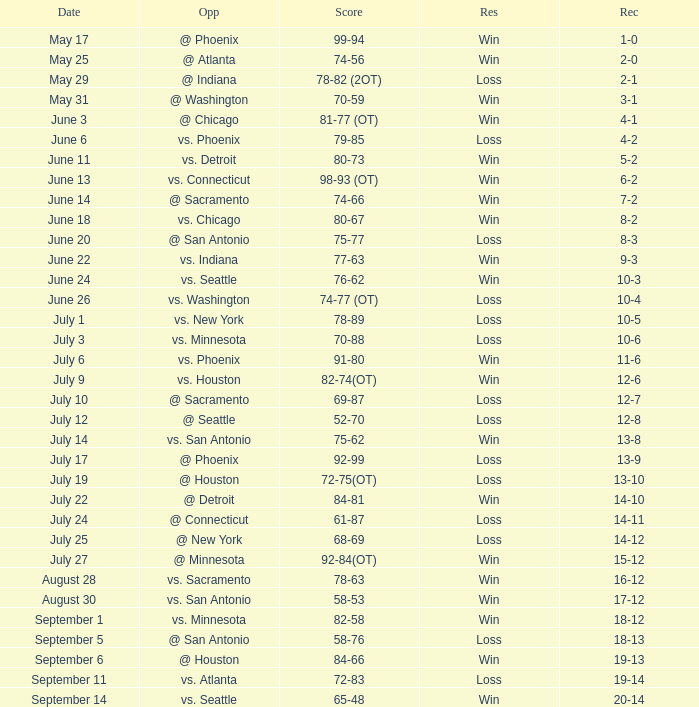What is the Record of the game on September 6? 19-13. 